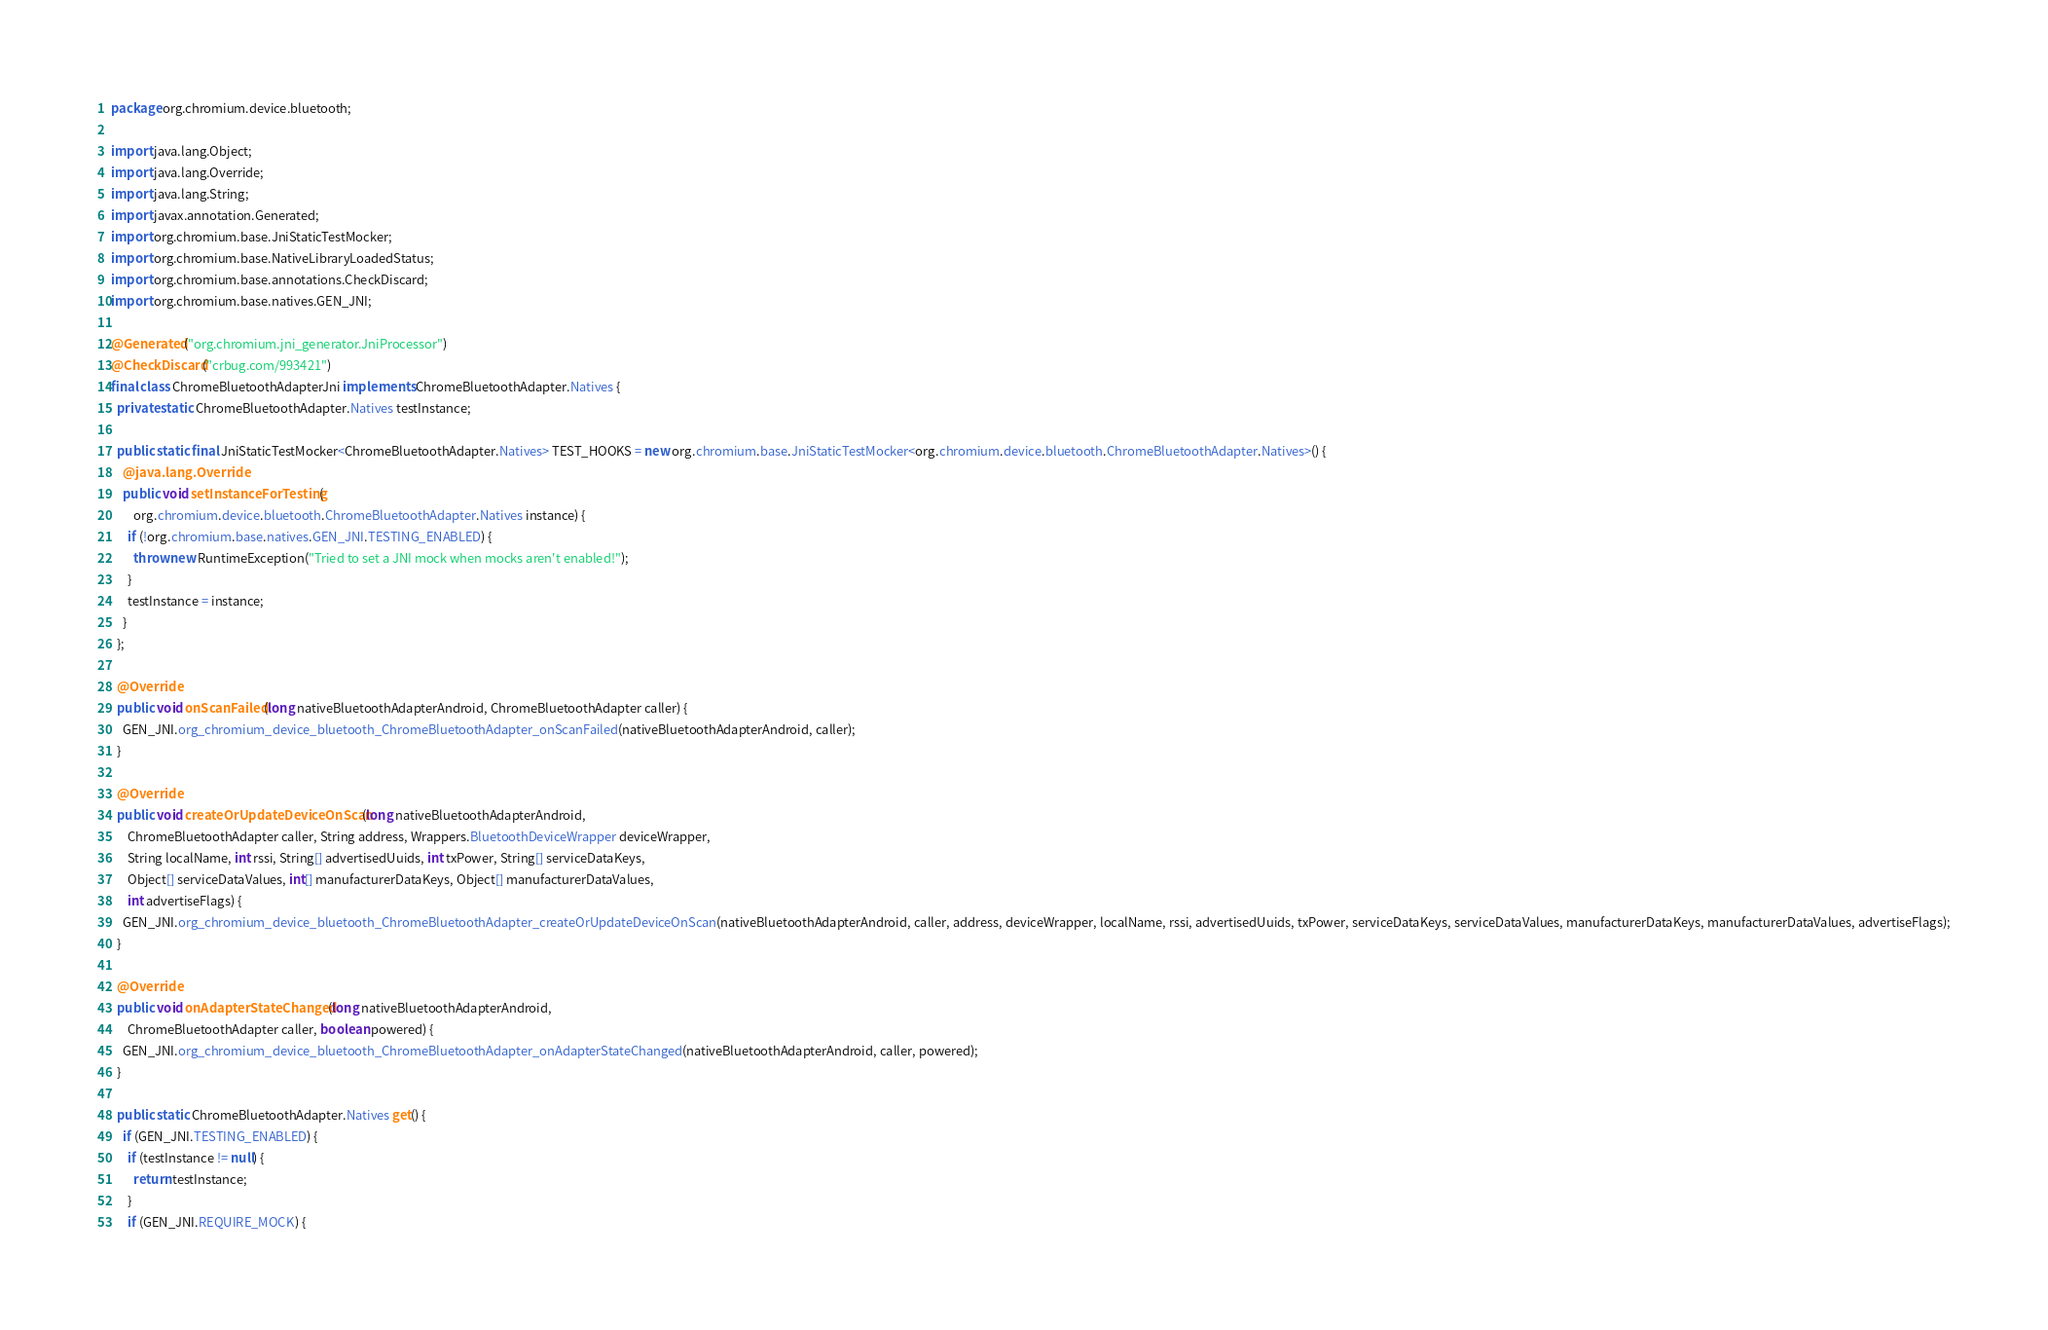<code> <loc_0><loc_0><loc_500><loc_500><_Java_>package org.chromium.device.bluetooth;

import java.lang.Object;
import java.lang.Override;
import java.lang.String;
import javax.annotation.Generated;
import org.chromium.base.JniStaticTestMocker;
import org.chromium.base.NativeLibraryLoadedStatus;
import org.chromium.base.annotations.CheckDiscard;
import org.chromium.base.natives.GEN_JNI;

@Generated("org.chromium.jni_generator.JniProcessor")
@CheckDiscard("crbug.com/993421")
final class ChromeBluetoothAdapterJni implements ChromeBluetoothAdapter.Natives {
  private static ChromeBluetoothAdapter.Natives testInstance;

  public static final JniStaticTestMocker<ChromeBluetoothAdapter.Natives> TEST_HOOKS = new org.chromium.base.JniStaticTestMocker<org.chromium.device.bluetooth.ChromeBluetoothAdapter.Natives>() {
    @java.lang.Override
    public void setInstanceForTesting(
        org.chromium.device.bluetooth.ChromeBluetoothAdapter.Natives instance) {
      if (!org.chromium.base.natives.GEN_JNI.TESTING_ENABLED) {
        throw new RuntimeException("Tried to set a JNI mock when mocks aren't enabled!");
      }
      testInstance = instance;
    }
  };

  @Override
  public void onScanFailed(long nativeBluetoothAdapterAndroid, ChromeBluetoothAdapter caller) {
    GEN_JNI.org_chromium_device_bluetooth_ChromeBluetoothAdapter_onScanFailed(nativeBluetoothAdapterAndroid, caller);
  }

  @Override
  public void createOrUpdateDeviceOnScan(long nativeBluetoothAdapterAndroid,
      ChromeBluetoothAdapter caller, String address, Wrappers.BluetoothDeviceWrapper deviceWrapper,
      String localName, int rssi, String[] advertisedUuids, int txPower, String[] serviceDataKeys,
      Object[] serviceDataValues, int[] manufacturerDataKeys, Object[] manufacturerDataValues,
      int advertiseFlags) {
    GEN_JNI.org_chromium_device_bluetooth_ChromeBluetoothAdapter_createOrUpdateDeviceOnScan(nativeBluetoothAdapterAndroid, caller, address, deviceWrapper, localName, rssi, advertisedUuids, txPower, serviceDataKeys, serviceDataValues, manufacturerDataKeys, manufacturerDataValues, advertiseFlags);
  }

  @Override
  public void onAdapterStateChanged(long nativeBluetoothAdapterAndroid,
      ChromeBluetoothAdapter caller, boolean powered) {
    GEN_JNI.org_chromium_device_bluetooth_ChromeBluetoothAdapter_onAdapterStateChanged(nativeBluetoothAdapterAndroid, caller, powered);
  }

  public static ChromeBluetoothAdapter.Natives get() {
    if (GEN_JNI.TESTING_ENABLED) {
      if (testInstance != null) {
        return testInstance;
      }
      if (GEN_JNI.REQUIRE_MOCK) {</code> 